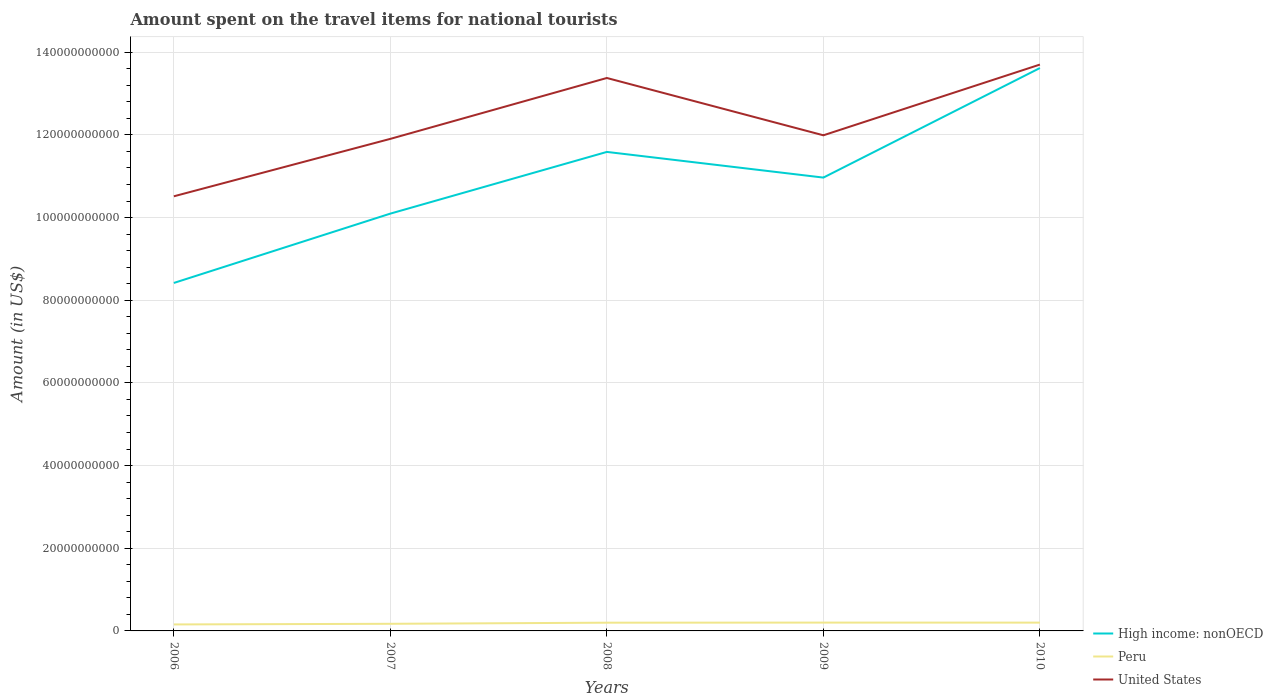How many different coloured lines are there?
Ensure brevity in your answer.  3. Across all years, what is the maximum amount spent on the travel items for national tourists in Peru?
Give a very brief answer. 1.57e+09. In which year was the amount spent on the travel items for national tourists in United States maximum?
Your answer should be compact. 2006. What is the total amount spent on the travel items for national tourists in United States in the graph?
Your answer should be compact. -3.19e+1. What is the difference between the highest and the second highest amount spent on the travel items for national tourists in Peru?
Provide a short and direct response. 4.44e+08. How many lines are there?
Your answer should be compact. 3. How many years are there in the graph?
Offer a terse response. 5. Are the values on the major ticks of Y-axis written in scientific E-notation?
Offer a terse response. No. How are the legend labels stacked?
Offer a terse response. Vertical. What is the title of the graph?
Your response must be concise. Amount spent on the travel items for national tourists. What is the Amount (in US$) in High income: nonOECD in 2006?
Offer a terse response. 8.42e+1. What is the Amount (in US$) in Peru in 2006?
Your answer should be very brief. 1.57e+09. What is the Amount (in US$) of United States in 2006?
Your answer should be compact. 1.05e+11. What is the Amount (in US$) of High income: nonOECD in 2007?
Keep it short and to the point. 1.01e+11. What is the Amount (in US$) of Peru in 2007?
Your answer should be very brief. 1.72e+09. What is the Amount (in US$) in United States in 2007?
Provide a succinct answer. 1.19e+11. What is the Amount (in US$) of High income: nonOECD in 2008?
Offer a very short reply. 1.16e+11. What is the Amount (in US$) in Peru in 2008?
Your response must be concise. 1.99e+09. What is the Amount (in US$) in United States in 2008?
Your answer should be compact. 1.34e+11. What is the Amount (in US$) of High income: nonOECD in 2009?
Offer a very short reply. 1.10e+11. What is the Amount (in US$) of Peru in 2009?
Offer a terse response. 2.01e+09. What is the Amount (in US$) of United States in 2009?
Provide a short and direct response. 1.20e+11. What is the Amount (in US$) of High income: nonOECD in 2010?
Ensure brevity in your answer.  1.36e+11. What is the Amount (in US$) in Peru in 2010?
Your answer should be compact. 2.01e+09. What is the Amount (in US$) in United States in 2010?
Your response must be concise. 1.37e+11. Across all years, what is the maximum Amount (in US$) of High income: nonOECD?
Make the answer very short. 1.36e+11. Across all years, what is the maximum Amount (in US$) in Peru?
Provide a succinct answer. 2.01e+09. Across all years, what is the maximum Amount (in US$) of United States?
Provide a succinct answer. 1.37e+11. Across all years, what is the minimum Amount (in US$) of High income: nonOECD?
Ensure brevity in your answer.  8.42e+1. Across all years, what is the minimum Amount (in US$) in Peru?
Offer a very short reply. 1.57e+09. Across all years, what is the minimum Amount (in US$) of United States?
Make the answer very short. 1.05e+11. What is the total Amount (in US$) of High income: nonOECD in the graph?
Give a very brief answer. 5.47e+11. What is the total Amount (in US$) of Peru in the graph?
Ensure brevity in your answer.  9.31e+09. What is the total Amount (in US$) of United States in the graph?
Your answer should be compact. 6.15e+11. What is the difference between the Amount (in US$) in High income: nonOECD in 2006 and that in 2007?
Offer a terse response. -1.68e+1. What is the difference between the Amount (in US$) of Peru in 2006 and that in 2007?
Your answer should be very brief. -1.53e+08. What is the difference between the Amount (in US$) in United States in 2006 and that in 2007?
Your response must be concise. -1.39e+1. What is the difference between the Amount (in US$) of High income: nonOECD in 2006 and that in 2008?
Keep it short and to the point. -3.17e+1. What is the difference between the Amount (in US$) of Peru in 2006 and that in 2008?
Keep it short and to the point. -4.21e+08. What is the difference between the Amount (in US$) of United States in 2006 and that in 2008?
Offer a very short reply. -2.86e+1. What is the difference between the Amount (in US$) in High income: nonOECD in 2006 and that in 2009?
Make the answer very short. -2.55e+1. What is the difference between the Amount (in US$) in Peru in 2006 and that in 2009?
Make the answer very short. -4.44e+08. What is the difference between the Amount (in US$) in United States in 2006 and that in 2009?
Your answer should be very brief. -1.48e+1. What is the difference between the Amount (in US$) in High income: nonOECD in 2006 and that in 2010?
Make the answer very short. -5.20e+1. What is the difference between the Amount (in US$) in Peru in 2006 and that in 2010?
Provide a succinct answer. -4.38e+08. What is the difference between the Amount (in US$) of United States in 2006 and that in 2010?
Keep it short and to the point. -3.19e+1. What is the difference between the Amount (in US$) in High income: nonOECD in 2007 and that in 2008?
Offer a very short reply. -1.49e+1. What is the difference between the Amount (in US$) in Peru in 2007 and that in 2008?
Your response must be concise. -2.68e+08. What is the difference between the Amount (in US$) in United States in 2007 and that in 2008?
Ensure brevity in your answer.  -1.47e+1. What is the difference between the Amount (in US$) of High income: nonOECD in 2007 and that in 2009?
Your answer should be very brief. -8.72e+09. What is the difference between the Amount (in US$) in Peru in 2007 and that in 2009?
Give a very brief answer. -2.91e+08. What is the difference between the Amount (in US$) of United States in 2007 and that in 2009?
Your response must be concise. -8.63e+08. What is the difference between the Amount (in US$) in High income: nonOECD in 2007 and that in 2010?
Ensure brevity in your answer.  -3.52e+1. What is the difference between the Amount (in US$) in Peru in 2007 and that in 2010?
Your answer should be compact. -2.85e+08. What is the difference between the Amount (in US$) of United States in 2007 and that in 2010?
Offer a terse response. -1.80e+1. What is the difference between the Amount (in US$) in High income: nonOECD in 2008 and that in 2009?
Offer a terse response. 6.21e+09. What is the difference between the Amount (in US$) in Peru in 2008 and that in 2009?
Your answer should be compact. -2.30e+07. What is the difference between the Amount (in US$) in United States in 2008 and that in 2009?
Provide a succinct answer. 1.39e+1. What is the difference between the Amount (in US$) in High income: nonOECD in 2008 and that in 2010?
Provide a succinct answer. -2.03e+1. What is the difference between the Amount (in US$) in Peru in 2008 and that in 2010?
Your answer should be compact. -1.70e+07. What is the difference between the Amount (in US$) of United States in 2008 and that in 2010?
Offer a terse response. -3.24e+09. What is the difference between the Amount (in US$) of High income: nonOECD in 2009 and that in 2010?
Ensure brevity in your answer.  -2.65e+1. What is the difference between the Amount (in US$) of Peru in 2009 and that in 2010?
Provide a short and direct response. 6.00e+06. What is the difference between the Amount (in US$) of United States in 2009 and that in 2010?
Provide a succinct answer. -1.71e+1. What is the difference between the Amount (in US$) of High income: nonOECD in 2006 and the Amount (in US$) of Peru in 2007?
Ensure brevity in your answer.  8.25e+1. What is the difference between the Amount (in US$) in High income: nonOECD in 2006 and the Amount (in US$) in United States in 2007?
Make the answer very short. -3.49e+1. What is the difference between the Amount (in US$) of Peru in 2006 and the Amount (in US$) of United States in 2007?
Your response must be concise. -1.17e+11. What is the difference between the Amount (in US$) in High income: nonOECD in 2006 and the Amount (in US$) in Peru in 2008?
Your answer should be very brief. 8.22e+1. What is the difference between the Amount (in US$) in High income: nonOECD in 2006 and the Amount (in US$) in United States in 2008?
Your response must be concise. -4.96e+1. What is the difference between the Amount (in US$) of Peru in 2006 and the Amount (in US$) of United States in 2008?
Your answer should be compact. -1.32e+11. What is the difference between the Amount (in US$) of High income: nonOECD in 2006 and the Amount (in US$) of Peru in 2009?
Ensure brevity in your answer.  8.22e+1. What is the difference between the Amount (in US$) in High income: nonOECD in 2006 and the Amount (in US$) in United States in 2009?
Your response must be concise. -3.57e+1. What is the difference between the Amount (in US$) in Peru in 2006 and the Amount (in US$) in United States in 2009?
Your answer should be very brief. -1.18e+11. What is the difference between the Amount (in US$) of High income: nonOECD in 2006 and the Amount (in US$) of Peru in 2010?
Your response must be concise. 8.22e+1. What is the difference between the Amount (in US$) in High income: nonOECD in 2006 and the Amount (in US$) in United States in 2010?
Your answer should be compact. -5.28e+1. What is the difference between the Amount (in US$) in Peru in 2006 and the Amount (in US$) in United States in 2010?
Provide a succinct answer. -1.35e+11. What is the difference between the Amount (in US$) of High income: nonOECD in 2007 and the Amount (in US$) of Peru in 2008?
Your response must be concise. 9.90e+1. What is the difference between the Amount (in US$) in High income: nonOECD in 2007 and the Amount (in US$) in United States in 2008?
Make the answer very short. -3.28e+1. What is the difference between the Amount (in US$) in Peru in 2007 and the Amount (in US$) in United States in 2008?
Your answer should be very brief. -1.32e+11. What is the difference between the Amount (in US$) in High income: nonOECD in 2007 and the Amount (in US$) in Peru in 2009?
Your response must be concise. 9.89e+1. What is the difference between the Amount (in US$) in High income: nonOECD in 2007 and the Amount (in US$) in United States in 2009?
Offer a terse response. -1.89e+1. What is the difference between the Amount (in US$) in Peru in 2007 and the Amount (in US$) in United States in 2009?
Provide a succinct answer. -1.18e+11. What is the difference between the Amount (in US$) of High income: nonOECD in 2007 and the Amount (in US$) of Peru in 2010?
Make the answer very short. 9.89e+1. What is the difference between the Amount (in US$) of High income: nonOECD in 2007 and the Amount (in US$) of United States in 2010?
Make the answer very short. -3.61e+1. What is the difference between the Amount (in US$) in Peru in 2007 and the Amount (in US$) in United States in 2010?
Offer a terse response. -1.35e+11. What is the difference between the Amount (in US$) in High income: nonOECD in 2008 and the Amount (in US$) in Peru in 2009?
Provide a succinct answer. 1.14e+11. What is the difference between the Amount (in US$) in High income: nonOECD in 2008 and the Amount (in US$) in United States in 2009?
Make the answer very short. -4.02e+09. What is the difference between the Amount (in US$) in Peru in 2008 and the Amount (in US$) in United States in 2009?
Ensure brevity in your answer.  -1.18e+11. What is the difference between the Amount (in US$) in High income: nonOECD in 2008 and the Amount (in US$) in Peru in 2010?
Your answer should be compact. 1.14e+11. What is the difference between the Amount (in US$) of High income: nonOECD in 2008 and the Amount (in US$) of United States in 2010?
Provide a succinct answer. -2.11e+1. What is the difference between the Amount (in US$) of Peru in 2008 and the Amount (in US$) of United States in 2010?
Offer a terse response. -1.35e+11. What is the difference between the Amount (in US$) of High income: nonOECD in 2009 and the Amount (in US$) of Peru in 2010?
Your response must be concise. 1.08e+11. What is the difference between the Amount (in US$) in High income: nonOECD in 2009 and the Amount (in US$) in United States in 2010?
Your answer should be very brief. -2.73e+1. What is the difference between the Amount (in US$) in Peru in 2009 and the Amount (in US$) in United States in 2010?
Make the answer very short. -1.35e+11. What is the average Amount (in US$) in High income: nonOECD per year?
Ensure brevity in your answer.  1.09e+11. What is the average Amount (in US$) in Peru per year?
Provide a short and direct response. 1.86e+09. What is the average Amount (in US$) of United States per year?
Your answer should be compact. 1.23e+11. In the year 2006, what is the difference between the Amount (in US$) of High income: nonOECD and Amount (in US$) of Peru?
Your answer should be compact. 8.26e+1. In the year 2006, what is the difference between the Amount (in US$) of High income: nonOECD and Amount (in US$) of United States?
Make the answer very short. -2.10e+1. In the year 2006, what is the difference between the Amount (in US$) in Peru and Amount (in US$) in United States?
Provide a short and direct response. -1.04e+11. In the year 2007, what is the difference between the Amount (in US$) in High income: nonOECD and Amount (in US$) in Peru?
Give a very brief answer. 9.92e+1. In the year 2007, what is the difference between the Amount (in US$) of High income: nonOECD and Amount (in US$) of United States?
Make the answer very short. -1.81e+1. In the year 2007, what is the difference between the Amount (in US$) of Peru and Amount (in US$) of United States?
Your response must be concise. -1.17e+11. In the year 2008, what is the difference between the Amount (in US$) of High income: nonOECD and Amount (in US$) of Peru?
Your answer should be very brief. 1.14e+11. In the year 2008, what is the difference between the Amount (in US$) in High income: nonOECD and Amount (in US$) in United States?
Provide a short and direct response. -1.79e+1. In the year 2008, what is the difference between the Amount (in US$) of Peru and Amount (in US$) of United States?
Offer a terse response. -1.32e+11. In the year 2009, what is the difference between the Amount (in US$) of High income: nonOECD and Amount (in US$) of Peru?
Your response must be concise. 1.08e+11. In the year 2009, what is the difference between the Amount (in US$) of High income: nonOECD and Amount (in US$) of United States?
Make the answer very short. -1.02e+1. In the year 2009, what is the difference between the Amount (in US$) in Peru and Amount (in US$) in United States?
Keep it short and to the point. -1.18e+11. In the year 2010, what is the difference between the Amount (in US$) in High income: nonOECD and Amount (in US$) in Peru?
Offer a very short reply. 1.34e+11. In the year 2010, what is the difference between the Amount (in US$) of High income: nonOECD and Amount (in US$) of United States?
Provide a short and direct response. -8.38e+08. In the year 2010, what is the difference between the Amount (in US$) in Peru and Amount (in US$) in United States?
Provide a short and direct response. -1.35e+11. What is the ratio of the Amount (in US$) in High income: nonOECD in 2006 to that in 2007?
Your answer should be compact. 0.83. What is the ratio of the Amount (in US$) of Peru in 2006 to that in 2007?
Your response must be concise. 0.91. What is the ratio of the Amount (in US$) in United States in 2006 to that in 2007?
Your answer should be very brief. 0.88. What is the ratio of the Amount (in US$) in High income: nonOECD in 2006 to that in 2008?
Offer a terse response. 0.73. What is the ratio of the Amount (in US$) in Peru in 2006 to that in 2008?
Keep it short and to the point. 0.79. What is the ratio of the Amount (in US$) in United States in 2006 to that in 2008?
Provide a succinct answer. 0.79. What is the ratio of the Amount (in US$) in High income: nonOECD in 2006 to that in 2009?
Make the answer very short. 0.77. What is the ratio of the Amount (in US$) in Peru in 2006 to that in 2009?
Your answer should be very brief. 0.78. What is the ratio of the Amount (in US$) of United States in 2006 to that in 2009?
Your answer should be compact. 0.88. What is the ratio of the Amount (in US$) of High income: nonOECD in 2006 to that in 2010?
Your answer should be compact. 0.62. What is the ratio of the Amount (in US$) of Peru in 2006 to that in 2010?
Provide a short and direct response. 0.78. What is the ratio of the Amount (in US$) of United States in 2006 to that in 2010?
Keep it short and to the point. 0.77. What is the ratio of the Amount (in US$) in High income: nonOECD in 2007 to that in 2008?
Give a very brief answer. 0.87. What is the ratio of the Amount (in US$) of Peru in 2007 to that in 2008?
Ensure brevity in your answer.  0.87. What is the ratio of the Amount (in US$) in United States in 2007 to that in 2008?
Make the answer very short. 0.89. What is the ratio of the Amount (in US$) in High income: nonOECD in 2007 to that in 2009?
Your response must be concise. 0.92. What is the ratio of the Amount (in US$) of Peru in 2007 to that in 2009?
Make the answer very short. 0.86. What is the ratio of the Amount (in US$) of United States in 2007 to that in 2009?
Keep it short and to the point. 0.99. What is the ratio of the Amount (in US$) of High income: nonOECD in 2007 to that in 2010?
Offer a terse response. 0.74. What is the ratio of the Amount (in US$) in Peru in 2007 to that in 2010?
Ensure brevity in your answer.  0.86. What is the ratio of the Amount (in US$) in United States in 2007 to that in 2010?
Keep it short and to the point. 0.87. What is the ratio of the Amount (in US$) in High income: nonOECD in 2008 to that in 2009?
Your answer should be very brief. 1.06. What is the ratio of the Amount (in US$) of United States in 2008 to that in 2009?
Offer a very short reply. 1.12. What is the ratio of the Amount (in US$) in High income: nonOECD in 2008 to that in 2010?
Your answer should be compact. 0.85. What is the ratio of the Amount (in US$) of United States in 2008 to that in 2010?
Your answer should be very brief. 0.98. What is the ratio of the Amount (in US$) in High income: nonOECD in 2009 to that in 2010?
Give a very brief answer. 0.81. What is the ratio of the Amount (in US$) of Peru in 2009 to that in 2010?
Ensure brevity in your answer.  1. What is the ratio of the Amount (in US$) in United States in 2009 to that in 2010?
Offer a terse response. 0.88. What is the difference between the highest and the second highest Amount (in US$) in High income: nonOECD?
Your response must be concise. 2.03e+1. What is the difference between the highest and the second highest Amount (in US$) of Peru?
Provide a succinct answer. 6.00e+06. What is the difference between the highest and the second highest Amount (in US$) in United States?
Offer a terse response. 3.24e+09. What is the difference between the highest and the lowest Amount (in US$) of High income: nonOECD?
Make the answer very short. 5.20e+1. What is the difference between the highest and the lowest Amount (in US$) in Peru?
Your response must be concise. 4.44e+08. What is the difference between the highest and the lowest Amount (in US$) of United States?
Provide a short and direct response. 3.19e+1. 